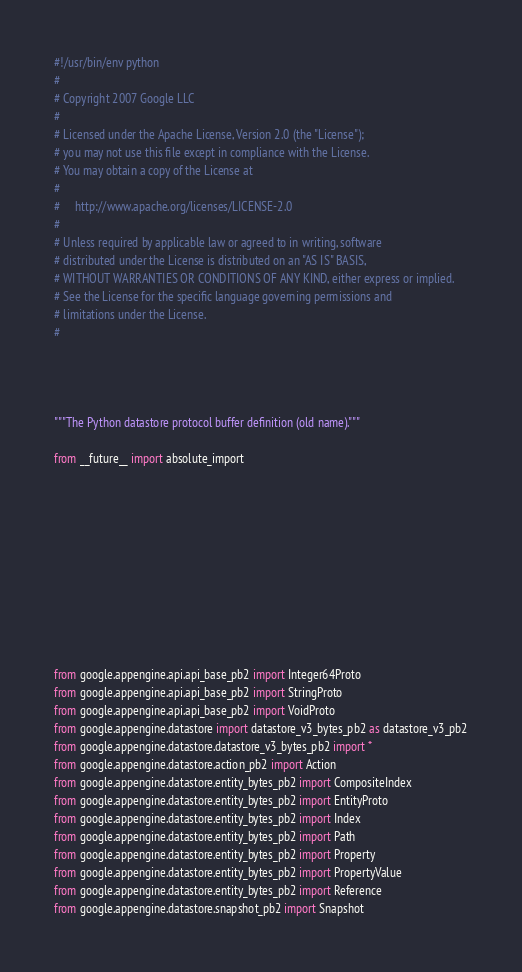<code> <loc_0><loc_0><loc_500><loc_500><_Python_>#!/usr/bin/env python
#
# Copyright 2007 Google LLC
#
# Licensed under the Apache License, Version 2.0 (the "License");
# you may not use this file except in compliance with the License.
# You may obtain a copy of the License at
#
#     http://www.apache.org/licenses/LICENSE-2.0
#
# Unless required by applicable law or agreed to in writing, software
# distributed under the License is distributed on an "AS IS" BASIS,
# WITHOUT WARRANTIES OR CONDITIONS OF ANY KIND, either express or implied.
# See the License for the specific language governing permissions and
# limitations under the License.
#




"""The Python datastore protocol buffer definition (old name)."""

from __future__ import absolute_import











from google.appengine.api.api_base_pb2 import Integer64Proto
from google.appengine.api.api_base_pb2 import StringProto
from google.appengine.api.api_base_pb2 import VoidProto
from google.appengine.datastore import datastore_v3_bytes_pb2 as datastore_v3_pb2
from google.appengine.datastore.datastore_v3_bytes_pb2 import *
from google.appengine.datastore.action_pb2 import Action
from google.appengine.datastore.entity_bytes_pb2 import CompositeIndex
from google.appengine.datastore.entity_bytes_pb2 import EntityProto
from google.appengine.datastore.entity_bytes_pb2 import Index
from google.appengine.datastore.entity_bytes_pb2 import Path
from google.appengine.datastore.entity_bytes_pb2 import Property
from google.appengine.datastore.entity_bytes_pb2 import PropertyValue
from google.appengine.datastore.entity_bytes_pb2 import Reference
from google.appengine.datastore.snapshot_pb2 import Snapshot
</code> 